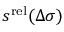<formula> <loc_0><loc_0><loc_500><loc_500>s ^ { r e l } ( \Delta \sigma )</formula> 